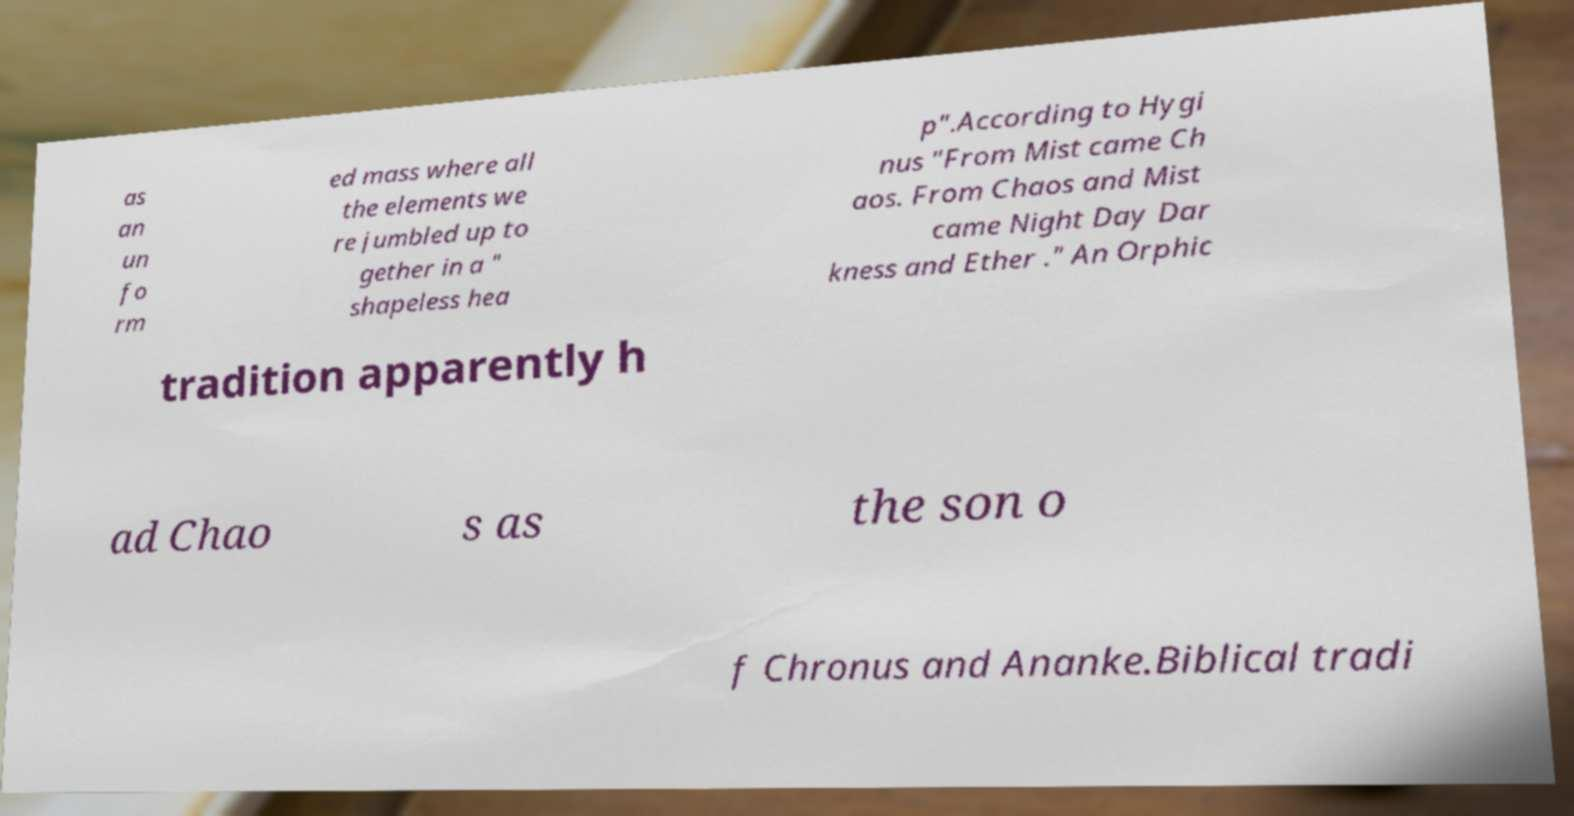I need the written content from this picture converted into text. Can you do that? as an un fo rm ed mass where all the elements we re jumbled up to gether in a " shapeless hea p".According to Hygi nus "From Mist came Ch aos. From Chaos and Mist came Night Day Dar kness and Ether ." An Orphic tradition apparently h ad Chao s as the son o f Chronus and Ananke.Biblical tradi 